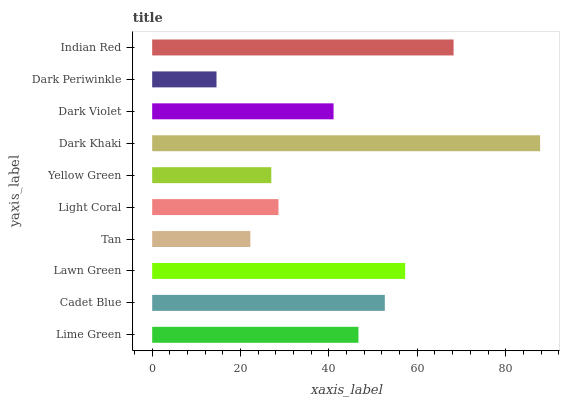Is Dark Periwinkle the minimum?
Answer yes or no. Yes. Is Dark Khaki the maximum?
Answer yes or no. Yes. Is Cadet Blue the minimum?
Answer yes or no. No. Is Cadet Blue the maximum?
Answer yes or no. No. Is Cadet Blue greater than Lime Green?
Answer yes or no. Yes. Is Lime Green less than Cadet Blue?
Answer yes or no. Yes. Is Lime Green greater than Cadet Blue?
Answer yes or no. No. Is Cadet Blue less than Lime Green?
Answer yes or no. No. Is Lime Green the high median?
Answer yes or no. Yes. Is Dark Violet the low median?
Answer yes or no. Yes. Is Dark Violet the high median?
Answer yes or no. No. Is Lawn Green the low median?
Answer yes or no. No. 